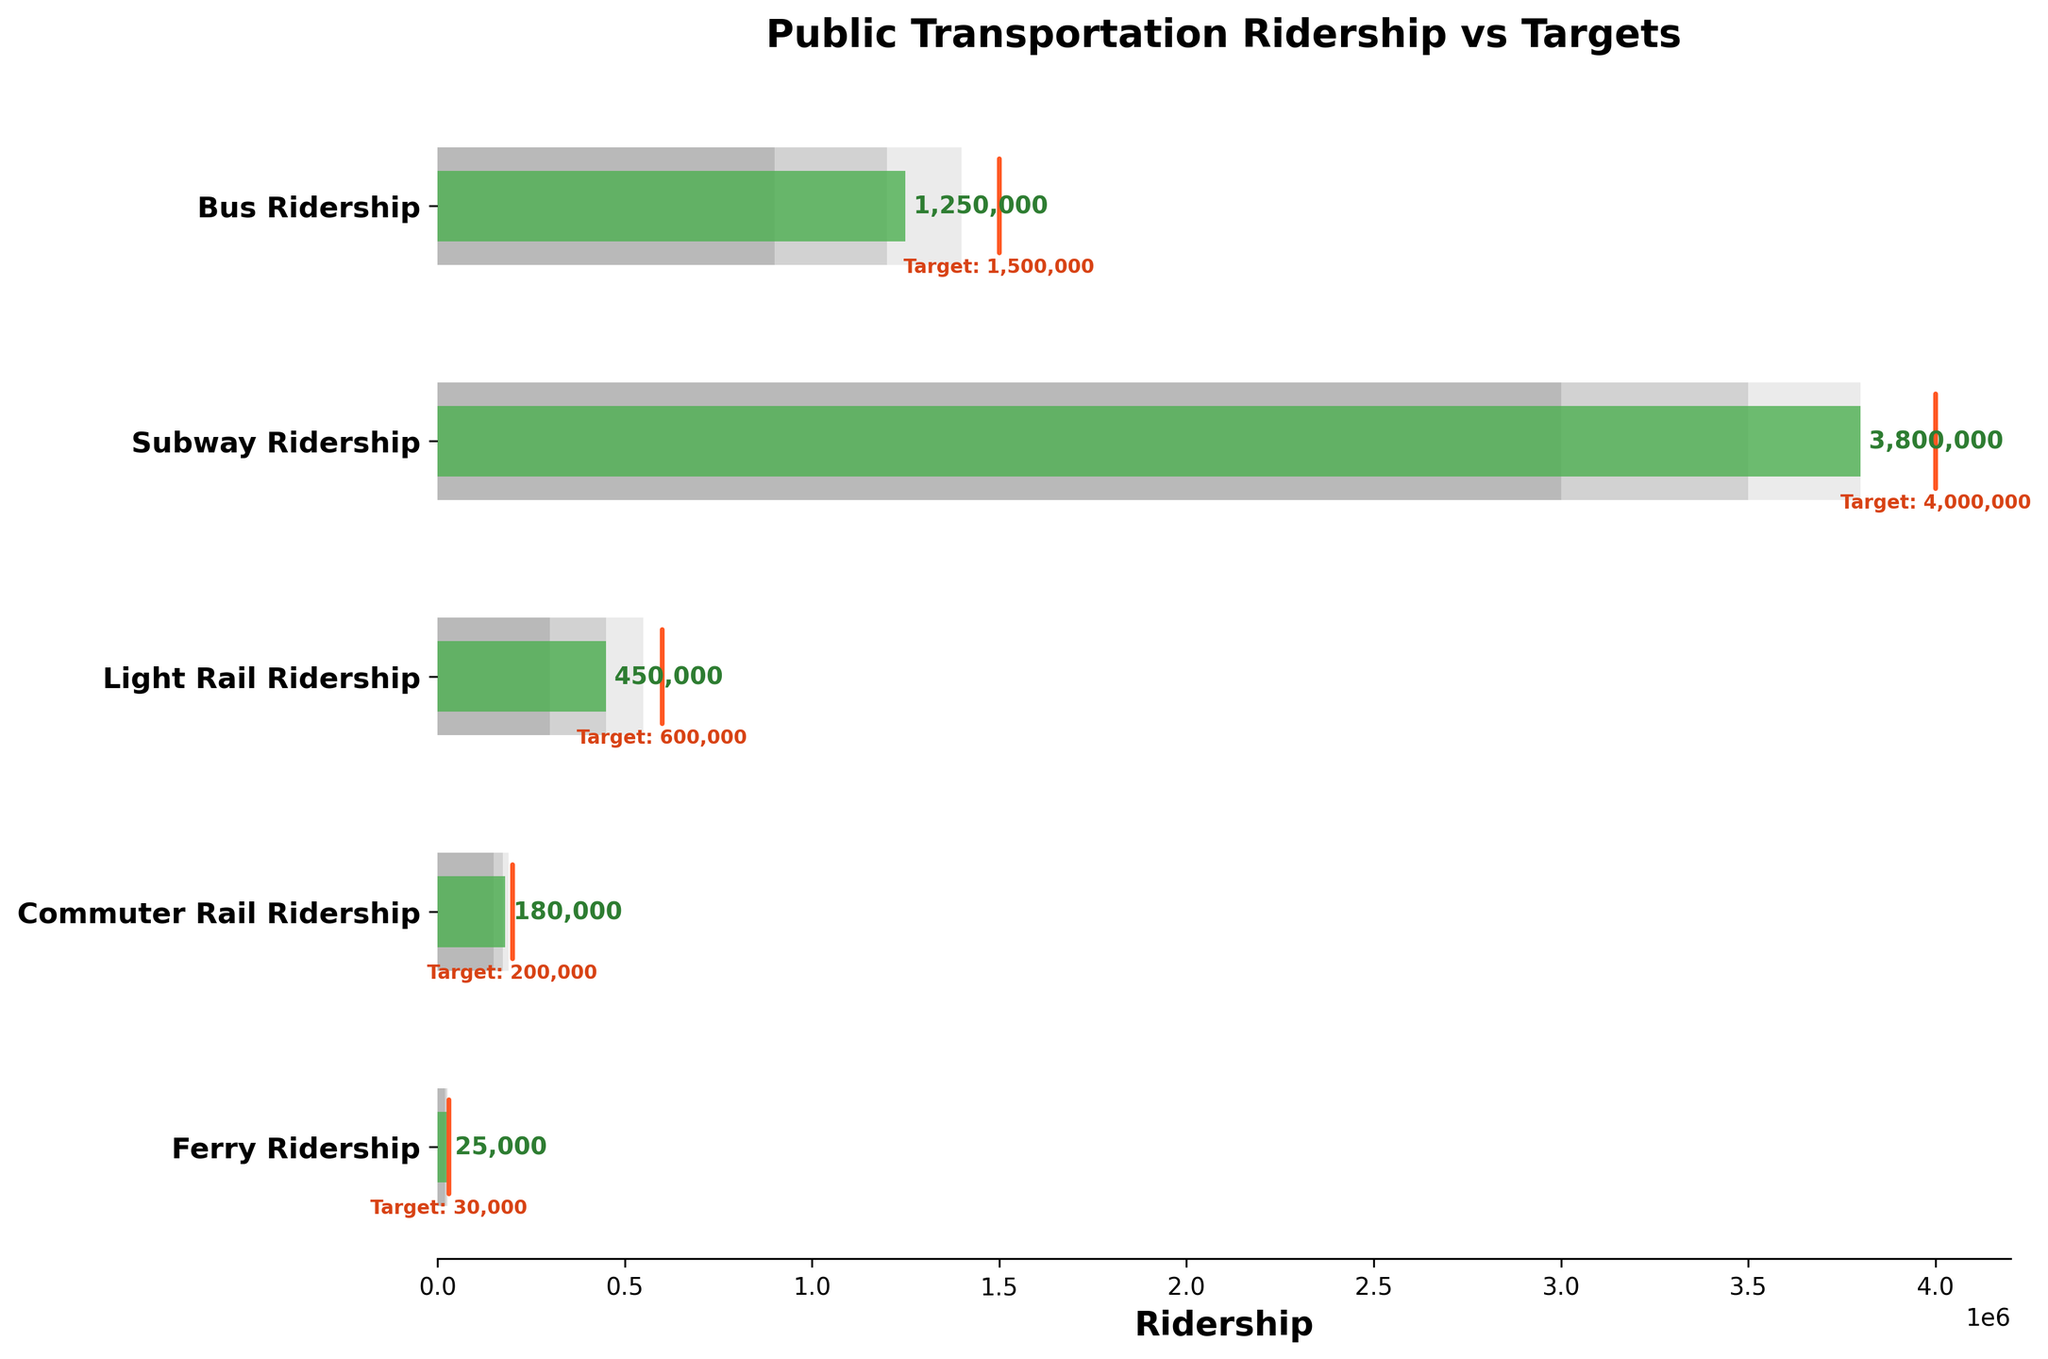What is the title of the figure? The title of the figure is usually displayed at the top and summarizes the main topic or data presented. In the given data, the title is "Public Transportation Ridership vs Targets".
Answer: Public Transportation Ridership vs Targets How many categories of public transportation are shown in the figure? The categories of public transportation are listed in the 'Title' column of the data. Counting the rows gives us the total number of categories.
Answer: 5 Which mode of transportation has the highest actual ridership? Referring to the 'Actual' values, the mode of transportation with the highest value is 'Subway Ridership' with 3,800,000.
Answer: Subway Ridership What is the target ridership for Commuter Rail Ridership? The target ridership is shown by the orange marker. For 'Commuter Rail Ridership', the target value listed is 200,000.
Answer: 200,000 Did the Ferry Ridership meet its target? Comparing the actual ridership (25,000) with the target ridership (30,000), the actual is less than the target, meaning it did not meet the target.
Answer: No Which categories achieved their target ridership? Checking each category's actual ridership against its target, 'Subway Ridership' (3,800,000 vs. 4,000,000) just falls short while all others also fall short of meeting their targets.
Answer: None What is the difference between the actual and target ridership for Light Rail Ridership? Subtract the actual ridership (450,000) from the target ridership (600,000). The difference is 150,000.
Answer: 150,000 Which mode of transportation's actual ridership is closest to its target? Calculate the difference between the actual and target ridership for each category. 'Subway Ridership' has the smallest difference of 200,000 (4,000,000 - 3,800,000).
Answer: Subway Ridership For Bus Ridership, is the actual closer to the upper or lower bound of the ranges? Comparing the actual ridership (1,250,000) to both the upper and lower bounds of the ranges (1,400,000 and 900,000), it is closer to the upper bound by a margin of 150,000.
Answer: Upper Which mode of transportation has the widest range between the lowest and highest target zones? The range is determined by the difference between the 'Range3' and 'Range1' values. For 'Subway Ridership', the range is 3,800,000 - 3,000,000 = 800,000, which is the widest.
Answer: Subway Ridership 